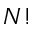<formula> <loc_0><loc_0><loc_500><loc_500>N !</formula> 